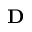Convert formula to latex. <formula><loc_0><loc_0><loc_500><loc_500>\mathbf D</formula> 